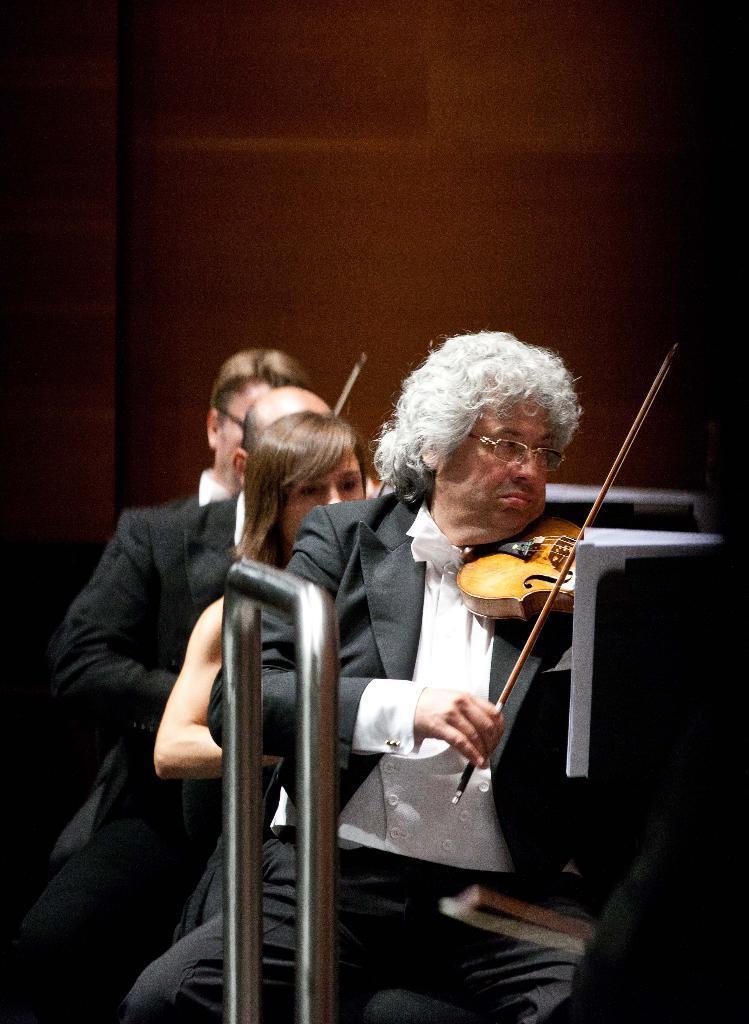Please provide a concise description of this image. In this picture we can see four persons, they are playing violin and in middle woman and in the background we can see wall, paper in front of them. 